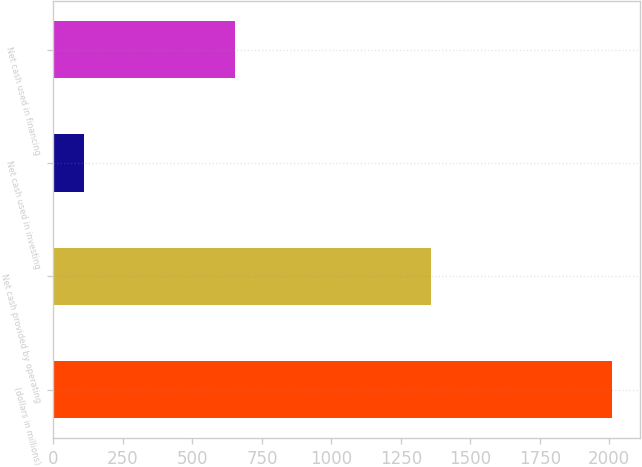<chart> <loc_0><loc_0><loc_500><loc_500><bar_chart><fcel>(dollars in millions)<fcel>Net cash provided by operating<fcel>Net cash used in investing<fcel>Net cash used in financing<nl><fcel>2010<fcel>1359.6<fcel>111.6<fcel>653.4<nl></chart> 